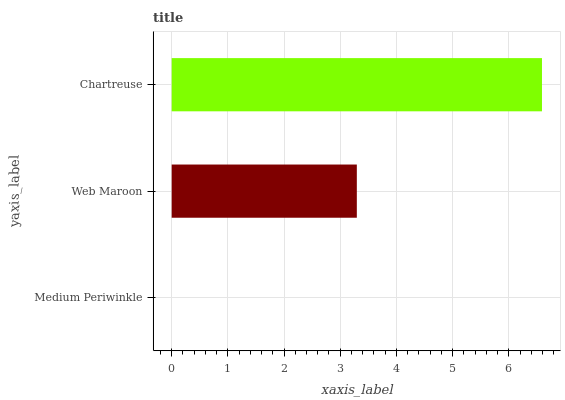Is Medium Periwinkle the minimum?
Answer yes or no. Yes. Is Chartreuse the maximum?
Answer yes or no. Yes. Is Web Maroon the minimum?
Answer yes or no. No. Is Web Maroon the maximum?
Answer yes or no. No. Is Web Maroon greater than Medium Periwinkle?
Answer yes or no. Yes. Is Medium Periwinkle less than Web Maroon?
Answer yes or no. Yes. Is Medium Periwinkle greater than Web Maroon?
Answer yes or no. No. Is Web Maroon less than Medium Periwinkle?
Answer yes or no. No. Is Web Maroon the high median?
Answer yes or no. Yes. Is Web Maroon the low median?
Answer yes or no. Yes. Is Chartreuse the high median?
Answer yes or no. No. Is Chartreuse the low median?
Answer yes or no. No. 